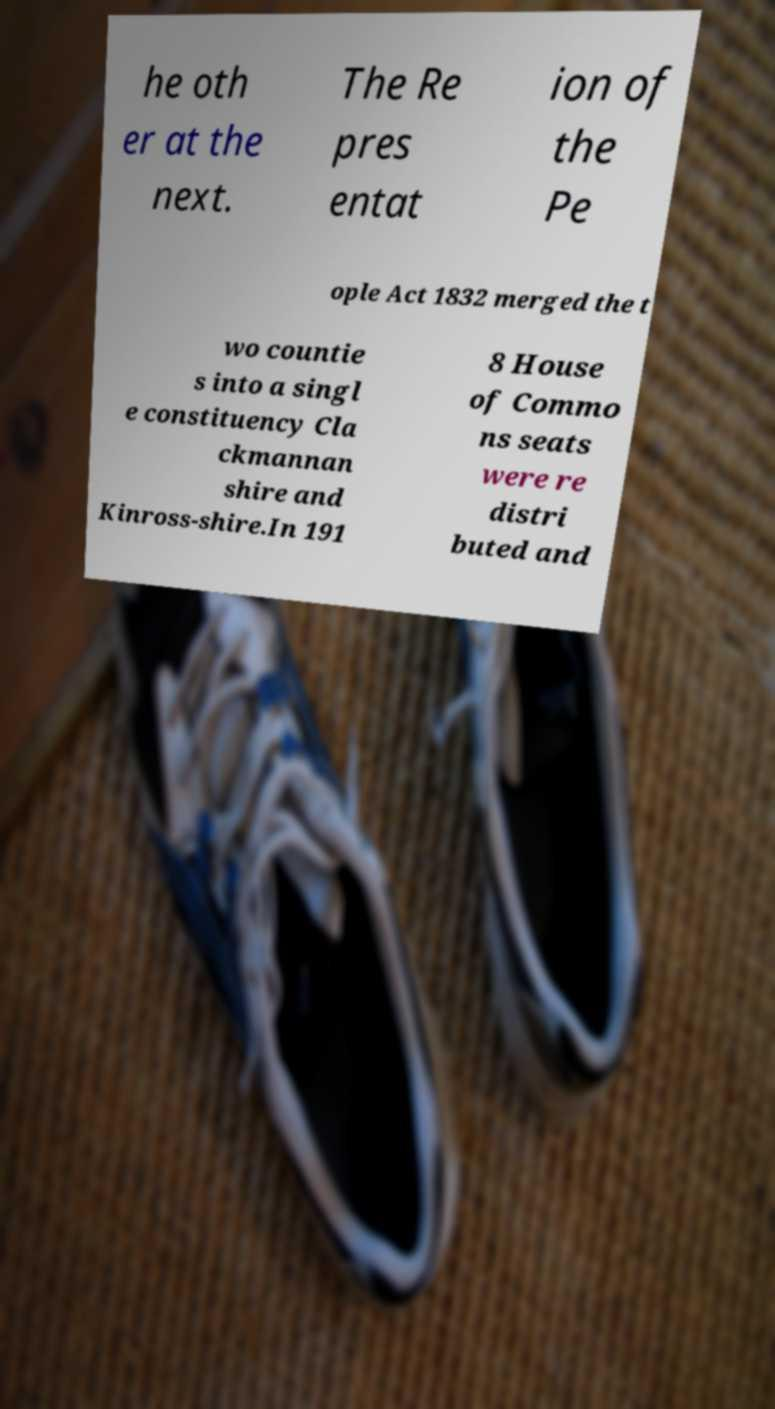For documentation purposes, I need the text within this image transcribed. Could you provide that? he oth er at the next. The Re pres entat ion of the Pe ople Act 1832 merged the t wo countie s into a singl e constituency Cla ckmannan shire and Kinross-shire.In 191 8 House of Commo ns seats were re distri buted and 